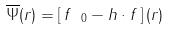Convert formula to latex. <formula><loc_0><loc_0><loc_500><loc_500>\overline { \Psi } ( r ) = \left [ \, f _ { \ 0 } - h \cdot f \, \right ] ( r )</formula> 